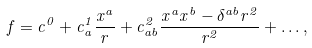<formula> <loc_0><loc_0><loc_500><loc_500>f = c ^ { 0 } + c _ { a } ^ { 1 } \frac { x ^ { a } } { r } + c ^ { 2 } _ { a b } \frac { x ^ { a } x ^ { b } - \delta ^ { a b } r ^ { 2 } } { r ^ { 2 } } + \dots ,</formula> 